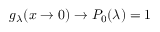Convert formula to latex. <formula><loc_0><loc_0><loc_500><loc_500>g _ { \lambda } ( x \rightarrow 0 ) \rightarrow P _ { 0 } ( \lambda ) = 1</formula> 